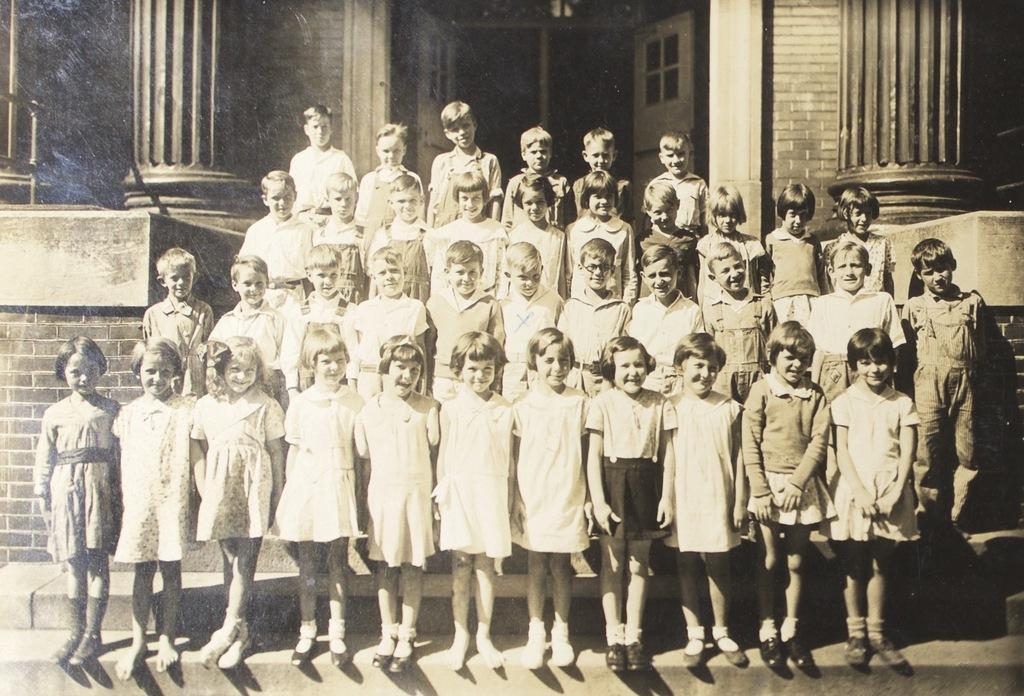Please provide a concise description of this image. It is a black and white image and in this image there are children standing on the steps of a building. 